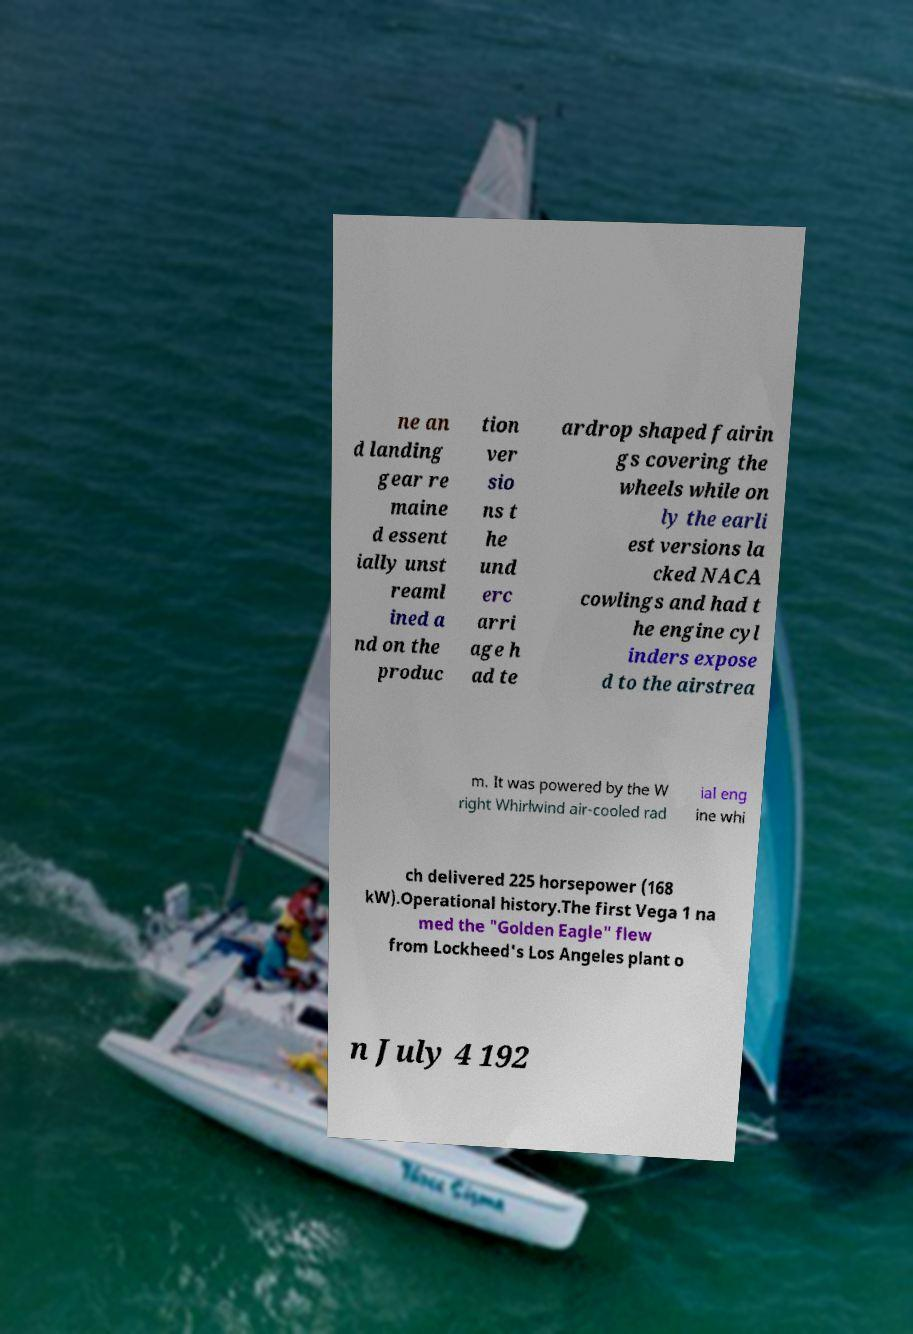I need the written content from this picture converted into text. Can you do that? ne an d landing gear re maine d essent ially unst reaml ined a nd on the produc tion ver sio ns t he und erc arri age h ad te ardrop shaped fairin gs covering the wheels while on ly the earli est versions la cked NACA cowlings and had t he engine cyl inders expose d to the airstrea m. It was powered by the W right Whirlwind air-cooled rad ial eng ine whi ch delivered 225 horsepower (168 kW).Operational history.The first Vega 1 na med the "Golden Eagle" flew from Lockheed's Los Angeles plant o n July 4 192 